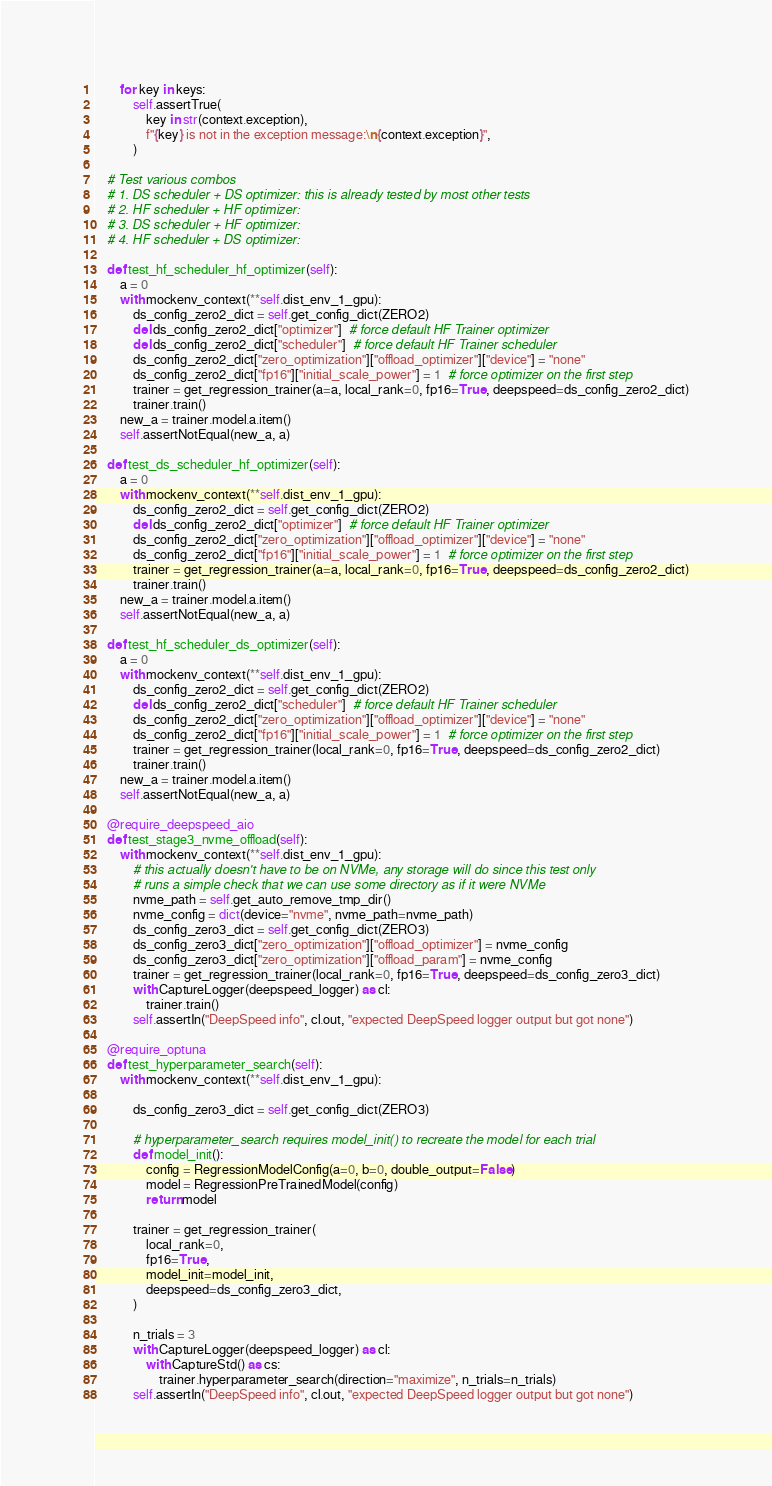Convert code to text. <code><loc_0><loc_0><loc_500><loc_500><_Python_>
        for key in keys:
            self.assertTrue(
                key in str(context.exception),
                f"{key} is not in the exception message:\n{context.exception}",
            )

    # Test various combos
    # 1. DS scheduler + DS optimizer: this is already tested by most other tests
    # 2. HF scheduler + HF optimizer:
    # 3. DS scheduler + HF optimizer:
    # 4. HF scheduler + DS optimizer:

    def test_hf_scheduler_hf_optimizer(self):
        a = 0
        with mockenv_context(**self.dist_env_1_gpu):
            ds_config_zero2_dict = self.get_config_dict(ZERO2)
            del ds_config_zero2_dict["optimizer"]  # force default HF Trainer optimizer
            del ds_config_zero2_dict["scheduler"]  # force default HF Trainer scheduler
            ds_config_zero2_dict["zero_optimization"]["offload_optimizer"]["device"] = "none"
            ds_config_zero2_dict["fp16"]["initial_scale_power"] = 1  # force optimizer on the first step
            trainer = get_regression_trainer(a=a, local_rank=0, fp16=True, deepspeed=ds_config_zero2_dict)
            trainer.train()
        new_a = trainer.model.a.item()
        self.assertNotEqual(new_a, a)

    def test_ds_scheduler_hf_optimizer(self):
        a = 0
        with mockenv_context(**self.dist_env_1_gpu):
            ds_config_zero2_dict = self.get_config_dict(ZERO2)
            del ds_config_zero2_dict["optimizer"]  # force default HF Trainer optimizer
            ds_config_zero2_dict["zero_optimization"]["offload_optimizer"]["device"] = "none"
            ds_config_zero2_dict["fp16"]["initial_scale_power"] = 1  # force optimizer on the first step
            trainer = get_regression_trainer(a=a, local_rank=0, fp16=True, deepspeed=ds_config_zero2_dict)
            trainer.train()
        new_a = trainer.model.a.item()
        self.assertNotEqual(new_a, a)

    def test_hf_scheduler_ds_optimizer(self):
        a = 0
        with mockenv_context(**self.dist_env_1_gpu):
            ds_config_zero2_dict = self.get_config_dict(ZERO2)
            del ds_config_zero2_dict["scheduler"]  # force default HF Trainer scheduler
            ds_config_zero2_dict["zero_optimization"]["offload_optimizer"]["device"] = "none"
            ds_config_zero2_dict["fp16"]["initial_scale_power"] = 1  # force optimizer on the first step
            trainer = get_regression_trainer(local_rank=0, fp16=True, deepspeed=ds_config_zero2_dict)
            trainer.train()
        new_a = trainer.model.a.item()
        self.assertNotEqual(new_a, a)

    @require_deepspeed_aio
    def test_stage3_nvme_offload(self):
        with mockenv_context(**self.dist_env_1_gpu):
            # this actually doesn't have to be on NVMe, any storage will do since this test only
            # runs a simple check that we can use some directory as if it were NVMe
            nvme_path = self.get_auto_remove_tmp_dir()
            nvme_config = dict(device="nvme", nvme_path=nvme_path)
            ds_config_zero3_dict = self.get_config_dict(ZERO3)
            ds_config_zero3_dict["zero_optimization"]["offload_optimizer"] = nvme_config
            ds_config_zero3_dict["zero_optimization"]["offload_param"] = nvme_config
            trainer = get_regression_trainer(local_rank=0, fp16=True, deepspeed=ds_config_zero3_dict)
            with CaptureLogger(deepspeed_logger) as cl:
                trainer.train()
            self.assertIn("DeepSpeed info", cl.out, "expected DeepSpeed logger output but got none")

    @require_optuna
    def test_hyperparameter_search(self):
        with mockenv_context(**self.dist_env_1_gpu):

            ds_config_zero3_dict = self.get_config_dict(ZERO3)

            # hyperparameter_search requires model_init() to recreate the model for each trial
            def model_init():
                config = RegressionModelConfig(a=0, b=0, double_output=False)
                model = RegressionPreTrainedModel(config)
                return model

            trainer = get_regression_trainer(
                local_rank=0,
                fp16=True,
                model_init=model_init,
                deepspeed=ds_config_zero3_dict,
            )

            n_trials = 3
            with CaptureLogger(deepspeed_logger) as cl:
                with CaptureStd() as cs:
                    trainer.hyperparameter_search(direction="maximize", n_trials=n_trials)
            self.assertIn("DeepSpeed info", cl.out, "expected DeepSpeed logger output but got none")</code> 